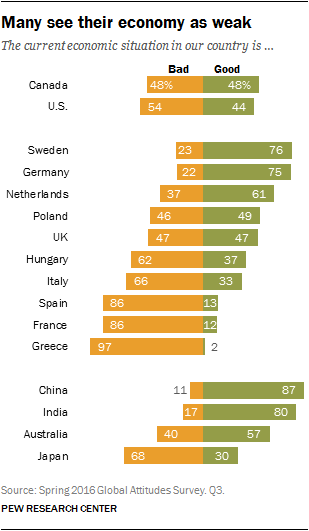Mention a couple of crucial points in this snapshot. Canada and the United Kingdom have both been given a value of Bad and Good opinions. According to a recent poll in the UK, 47% of respondents hold a favorable opinion of the country. 